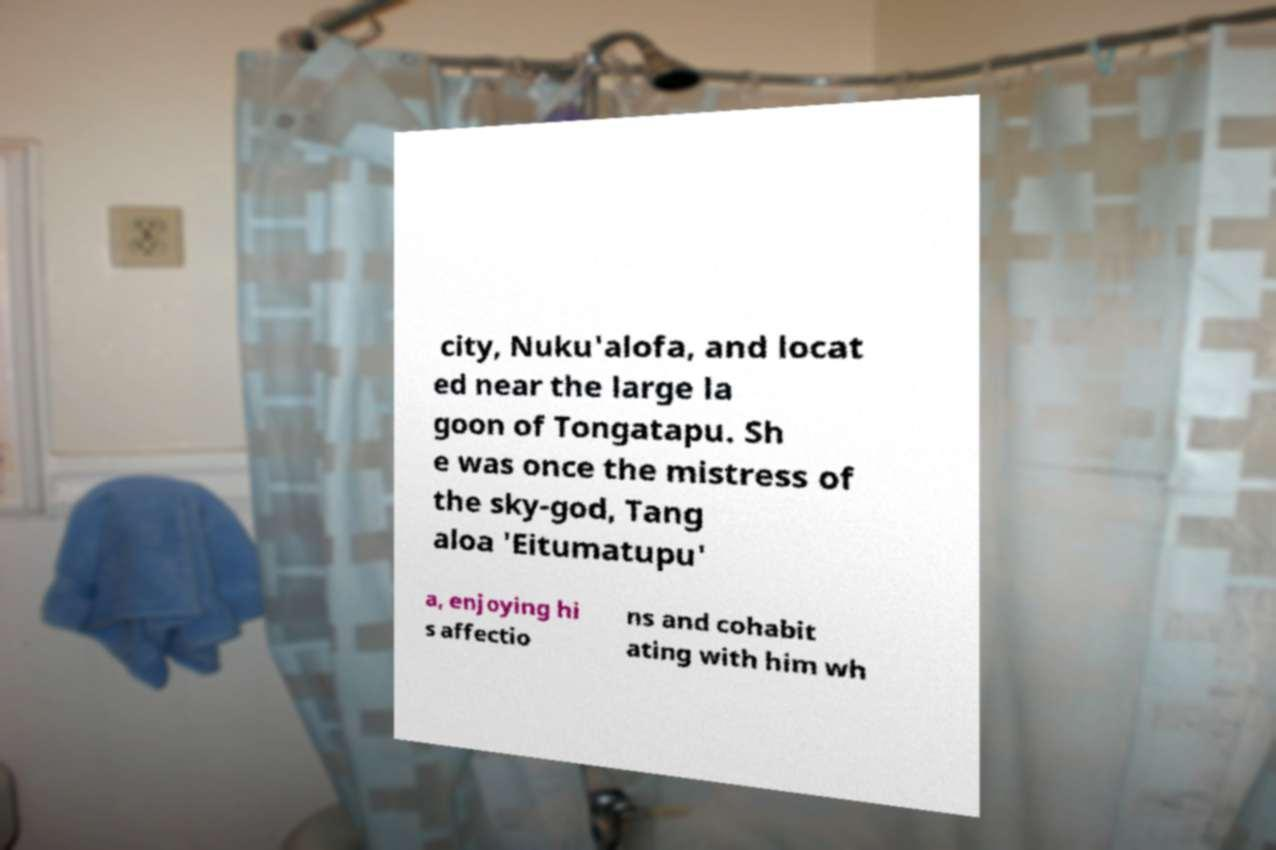For documentation purposes, I need the text within this image transcribed. Could you provide that? city, Nuku'alofa, and locat ed near the large la goon of Tongatapu. Sh e was once the mistress of the sky-god, Tang aloa 'Eitumatupu' a, enjoying hi s affectio ns and cohabit ating with him wh 